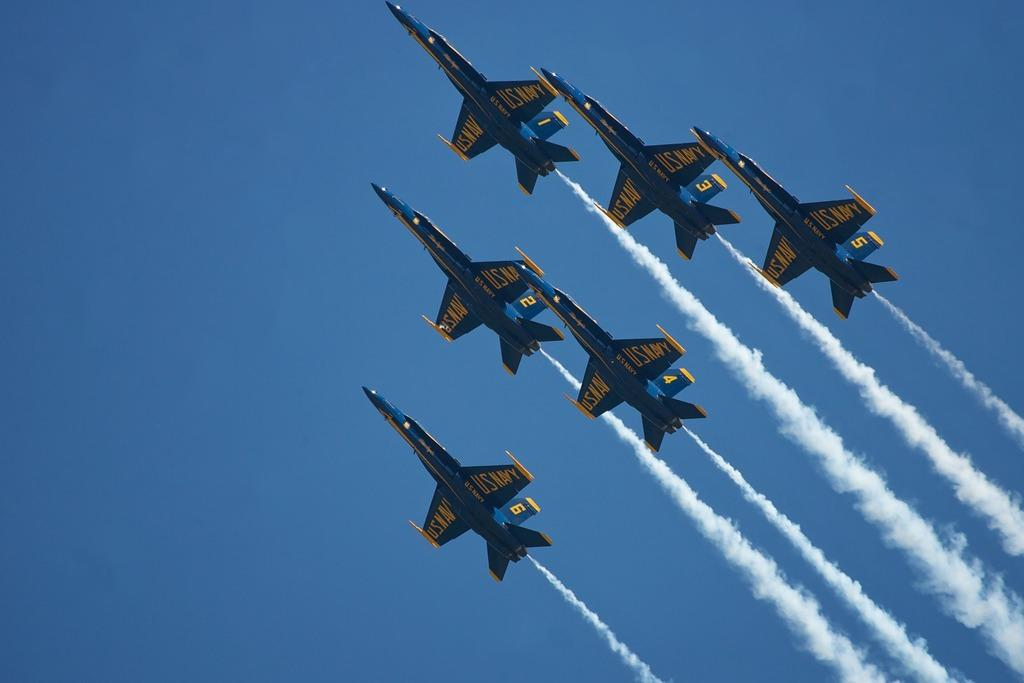What is the main subject of the image? The main subject of the image is many aircrafts. Are there any specific details on the aircrafts? Yes, there is text on the aircrafts. What can be seen in the air in the image? There is smoke in the air. What is visible in the background of the image? The sky is visible in the image. Can you tell me how many ants are crawling on the aircrafts in the image? There are no ants present in the image; it features aircrafts with text and smoke in the air. What color is the orange fruit in the image? There is no orange fruit present in the image. 